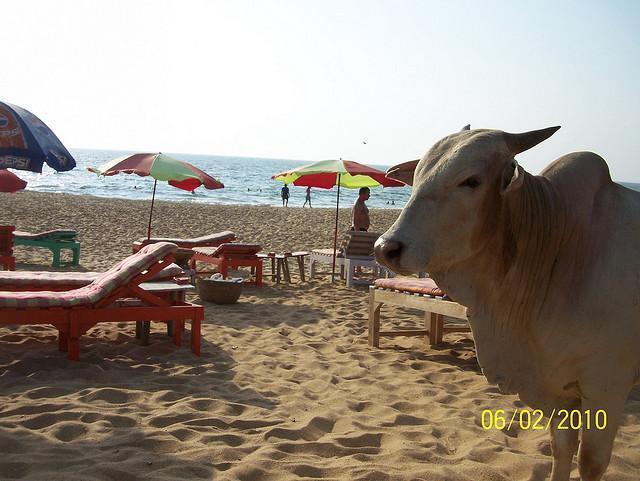Which sentient beings are able to swim?
Pick the correct solution from the four options below to address the question.
Options: Bugs, humans, goat, birds. Humans. 